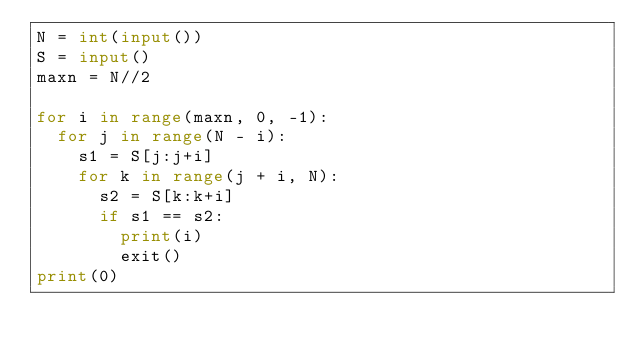<code> <loc_0><loc_0><loc_500><loc_500><_Python_>N = int(input())
S = input()
maxn = N//2

for i in range(maxn, 0, -1):
  for j in range(N - i):
    s1 = S[j:j+i]
    for k in range(j + i, N):
      s2 = S[k:k+i]
      if s1 == s2:
        print(i)
        exit()
print(0)</code> 